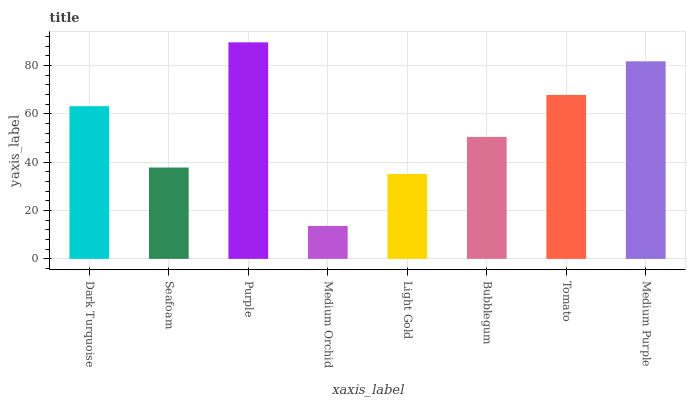Is Medium Orchid the minimum?
Answer yes or no. Yes. Is Purple the maximum?
Answer yes or no. Yes. Is Seafoam the minimum?
Answer yes or no. No. Is Seafoam the maximum?
Answer yes or no. No. Is Dark Turquoise greater than Seafoam?
Answer yes or no. Yes. Is Seafoam less than Dark Turquoise?
Answer yes or no. Yes. Is Seafoam greater than Dark Turquoise?
Answer yes or no. No. Is Dark Turquoise less than Seafoam?
Answer yes or no. No. Is Dark Turquoise the high median?
Answer yes or no. Yes. Is Bubblegum the low median?
Answer yes or no. Yes. Is Bubblegum the high median?
Answer yes or no. No. Is Tomato the low median?
Answer yes or no. No. 